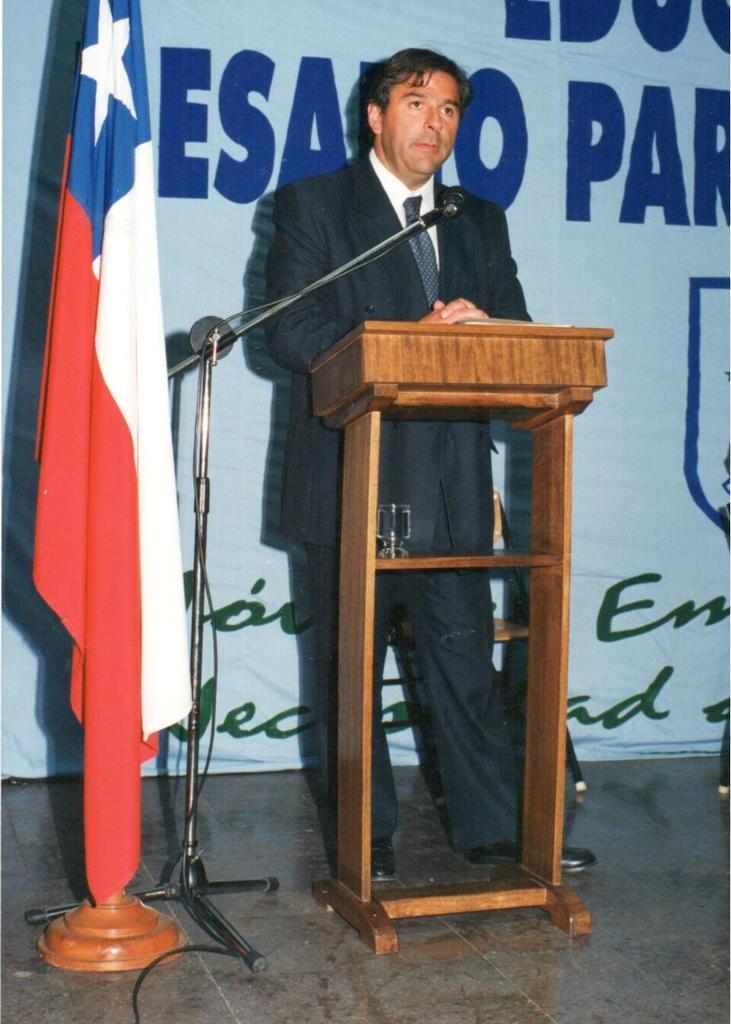Please provide a concise description of this image. There is a person standing. In front of him there is a stand. On the stand there is a glass. Near to that there is a mic with mic stand. Also there is a flag. In the back there is a wall with something written. 